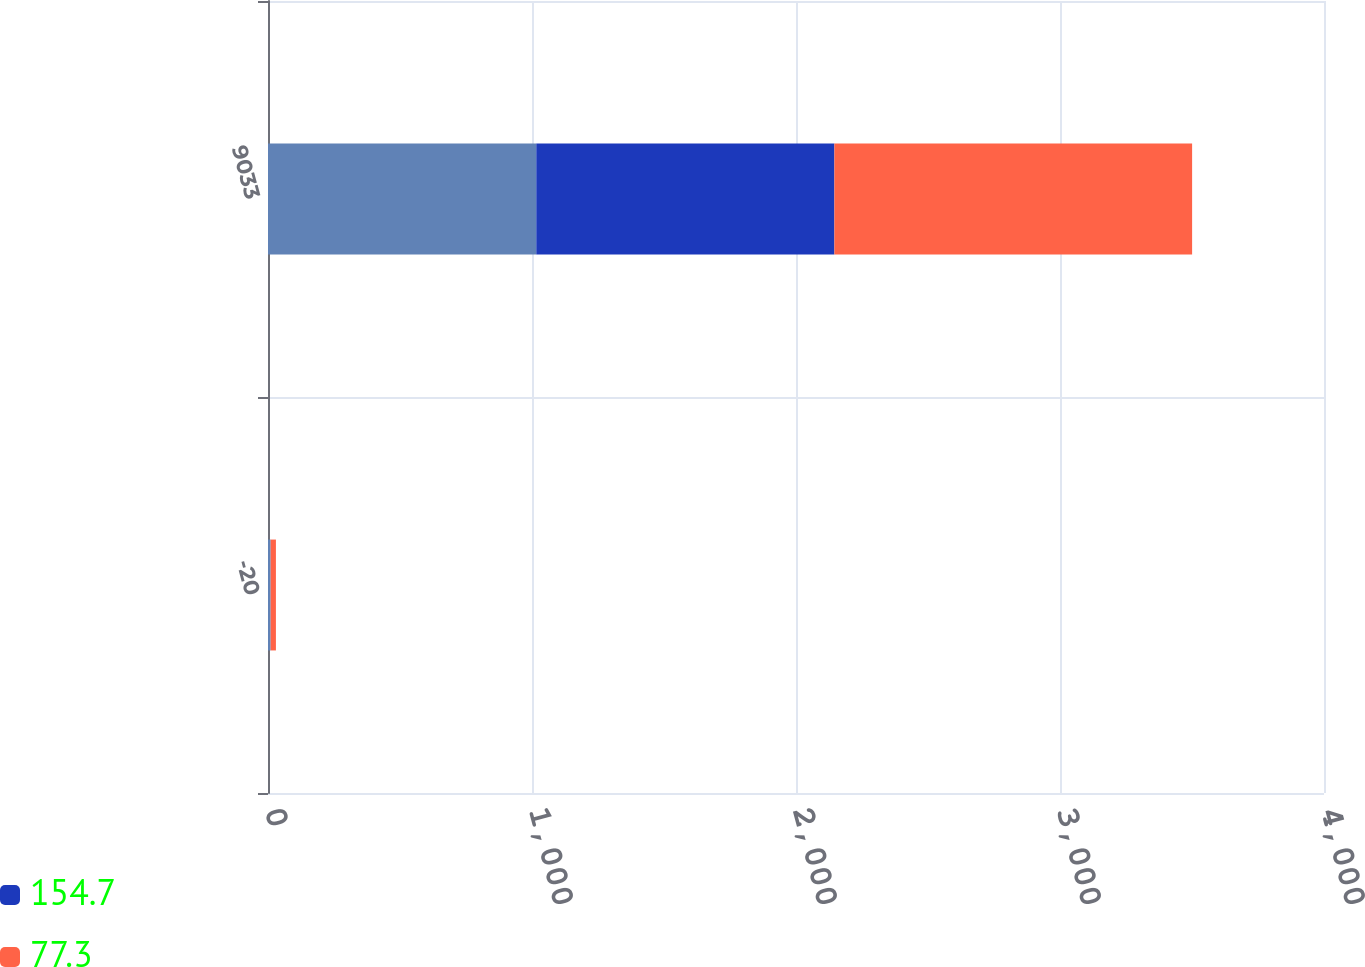Convert chart. <chart><loc_0><loc_0><loc_500><loc_500><stacked_bar_chart><ecel><fcel>-20<fcel>9033<nl><fcel>nan<fcel>10<fcel>1016.2<nl><fcel>154.7<fcel>0<fcel>1129.2<nl><fcel>77.3<fcel>20<fcel>1355<nl></chart> 